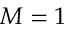<formula> <loc_0><loc_0><loc_500><loc_500>M = 1</formula> 